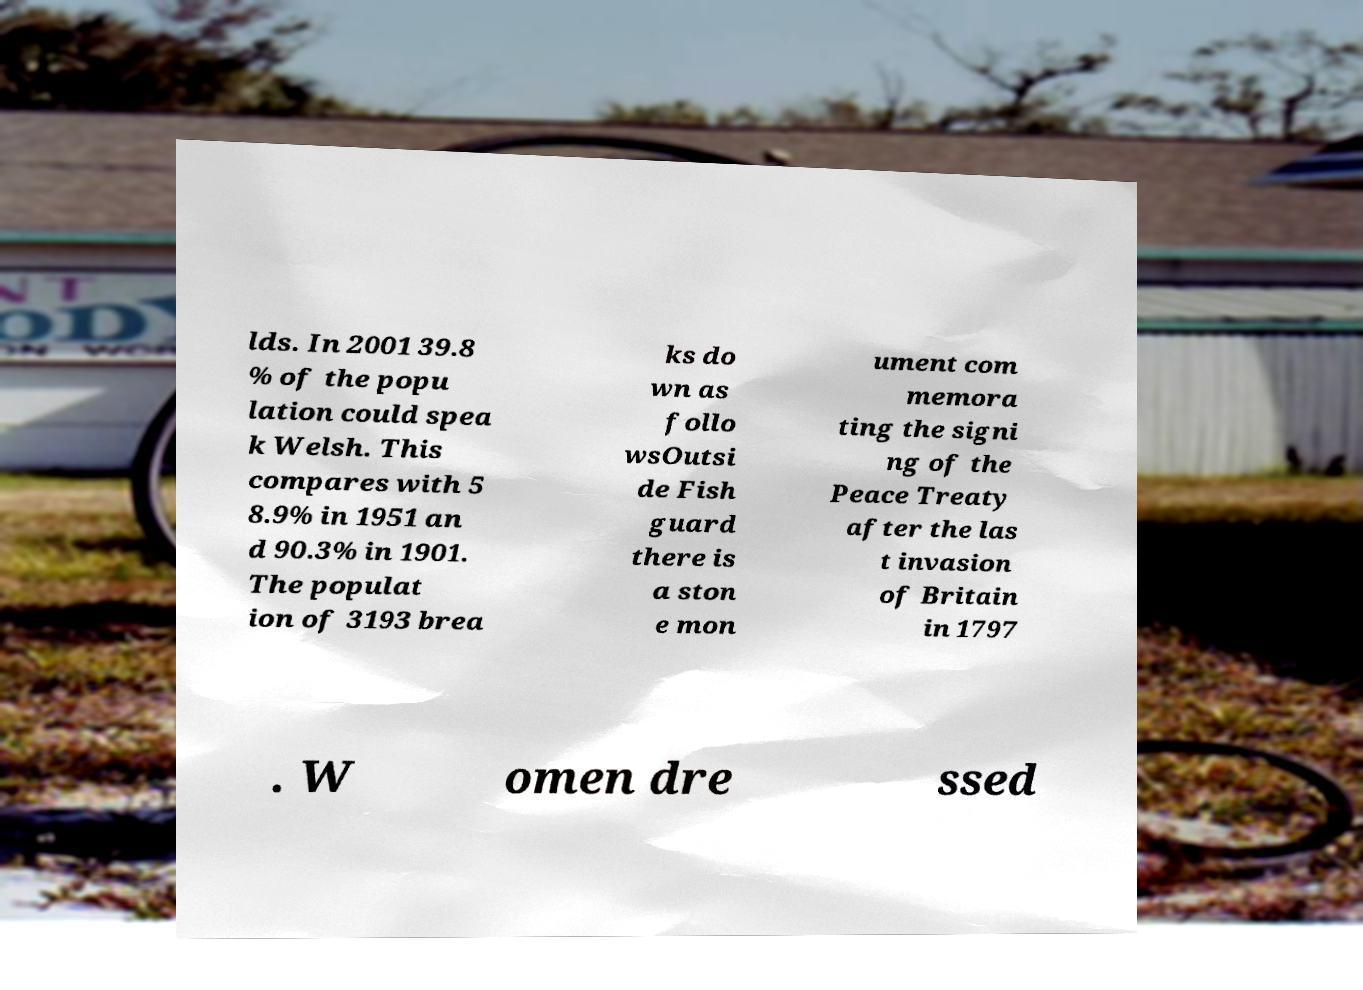For documentation purposes, I need the text within this image transcribed. Could you provide that? lds. In 2001 39.8 % of the popu lation could spea k Welsh. This compares with 5 8.9% in 1951 an d 90.3% in 1901. The populat ion of 3193 brea ks do wn as follo wsOutsi de Fish guard there is a ston e mon ument com memora ting the signi ng of the Peace Treaty after the las t invasion of Britain in 1797 . W omen dre ssed 